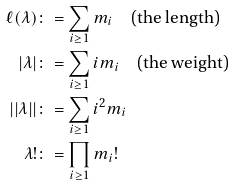<formula> <loc_0><loc_0><loc_500><loc_500>\ell ( \lambda ) & \colon = \sum _ { i \geq 1 } m _ { i } \quad \text {(the length)} \\ | \lambda | & \colon = \sum _ { i \geq 1 } i m _ { i } \quad \text {(the weight)} \\ | | \lambda | | & \colon = \sum _ { i \geq 1 } i ^ { 2 } m _ { i } \\ \lambda ! & \colon = \prod _ { i \geq 1 } m _ { i } !</formula> 